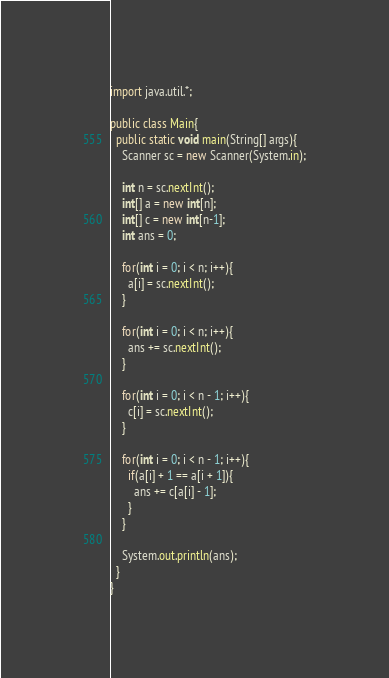Convert code to text. <code><loc_0><loc_0><loc_500><loc_500><_Java_>import java.util.*;

public class Main{
  public static void main(String[] args){
    Scanner sc = new Scanner(System.in);

    int n = sc.nextInt();
    int[] a = new int[n];
    int[] c = new int[n-1];
    int ans = 0;

    for(int i = 0; i < n; i++){
      a[i] = sc.nextInt();
    }

    for(int i = 0; i < n; i++){
      ans += sc.nextInt();
    }

    for(int i = 0; i < n - 1; i++){
      c[i] = sc.nextInt();
    }

    for(int i = 0; i < n - 1; i++){
      if(a[i] + 1 == a[i + 1]){
        ans += c[a[i] - 1];
      }
    }

    System.out.println(ans);
  }
}
</code> 